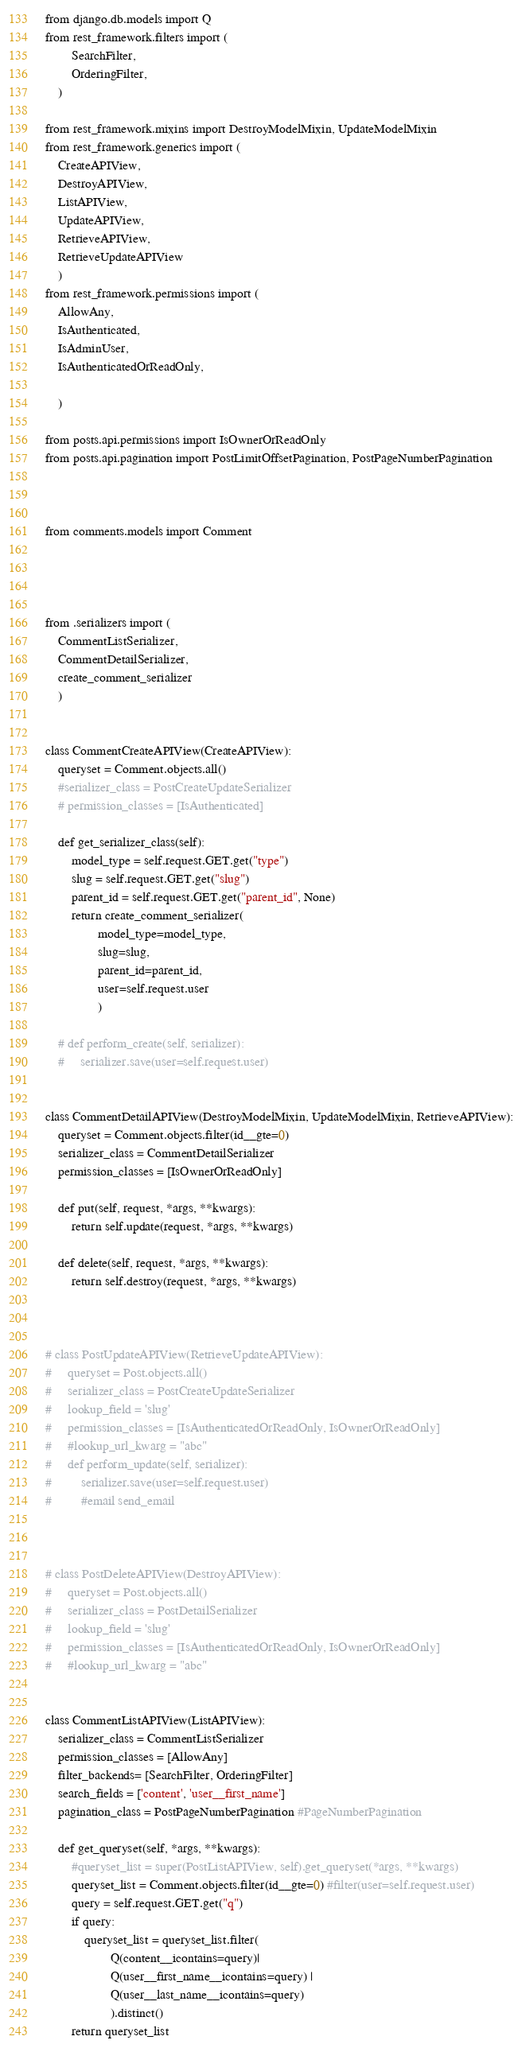Convert code to text. <code><loc_0><loc_0><loc_500><loc_500><_Python_>from django.db.models import Q
from rest_framework.filters import (
        SearchFilter,
        OrderingFilter,
    )

from rest_framework.mixins import DestroyModelMixin, UpdateModelMixin
from rest_framework.generics import (
    CreateAPIView,
    DestroyAPIView,
    ListAPIView, 
    UpdateAPIView,
    RetrieveAPIView,
    RetrieveUpdateAPIView
    )
from rest_framework.permissions import (
    AllowAny,
    IsAuthenticated,
    IsAdminUser,
    IsAuthenticatedOrReadOnly,

    )

from posts.api.permissions import IsOwnerOrReadOnly
from posts.api.pagination import PostLimitOffsetPagination, PostPageNumberPagination



from comments.models import Comment




from .serializers import (
    CommentListSerializer,
    CommentDetailSerializer,
    create_comment_serializer
    )


class CommentCreateAPIView(CreateAPIView):
    queryset = Comment.objects.all()
    #serializer_class = PostCreateUpdateSerializer
    # permission_classes = [IsAuthenticated]

    def get_serializer_class(self):
        model_type = self.request.GET.get("type")
        slug = self.request.GET.get("slug")
        parent_id = self.request.GET.get("parent_id", None)
        return create_comment_serializer(
                model_type=model_type, 
                slug=slug, 
                parent_id=parent_id,
                user=self.request.user
                )

    # def perform_create(self, serializer):
    #     serializer.save(user=self.request.user)


class CommentDetailAPIView(DestroyModelMixin, UpdateModelMixin, RetrieveAPIView):
    queryset = Comment.objects.filter(id__gte=0)
    serializer_class = CommentDetailSerializer
    permission_classes = [IsOwnerOrReadOnly]

    def put(self, request, *args, **kwargs):
        return self.update(request, *args, **kwargs)

    def delete(self, request, *args, **kwargs):
        return self.destroy(request, *args, **kwargs)



# class PostUpdateAPIView(RetrieveUpdateAPIView):
#     queryset = Post.objects.all()
#     serializer_class = PostCreateUpdateSerializer
#     lookup_field = 'slug'
#     permission_classes = [IsAuthenticatedOrReadOnly, IsOwnerOrReadOnly]
#     #lookup_url_kwarg = "abc"
#     def perform_update(self, serializer):
#         serializer.save(user=self.request.user)
#         #email send_email



# class PostDeleteAPIView(DestroyAPIView):
#     queryset = Post.objects.all()
#     serializer_class = PostDetailSerializer
#     lookup_field = 'slug'
#     permission_classes = [IsAuthenticatedOrReadOnly, IsOwnerOrReadOnly]
#     #lookup_url_kwarg = "abc"


class CommentListAPIView(ListAPIView):
    serializer_class = CommentListSerializer
    permission_classes = [AllowAny]
    filter_backends= [SearchFilter, OrderingFilter]
    search_fields = ['content', 'user__first_name']
    pagination_class = PostPageNumberPagination #PageNumberPagination

    def get_queryset(self, *args, **kwargs):
        #queryset_list = super(PostListAPIView, self).get_queryset(*args, **kwargs)
        queryset_list = Comment.objects.filter(id__gte=0) #filter(user=self.request.user)
        query = self.request.GET.get("q")
        if query:
            queryset_list = queryset_list.filter(
                    Q(content__icontains=query)|
                    Q(user__first_name__icontains=query) |
                    Q(user__last_name__icontains=query)
                    ).distinct()
        return queryset_list














</code> 